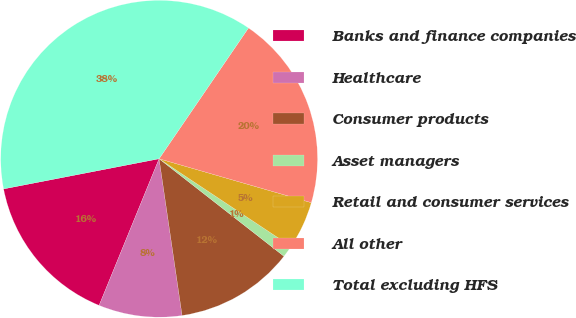Convert chart. <chart><loc_0><loc_0><loc_500><loc_500><pie_chart><fcel>Banks and finance companies<fcel>Healthcare<fcel>Consumer products<fcel>Asset managers<fcel>Retail and consumer services<fcel>All other<fcel>Total excluding HFS<nl><fcel>15.77%<fcel>8.5%<fcel>12.13%<fcel>1.22%<fcel>4.86%<fcel>19.93%<fcel>37.59%<nl></chart> 